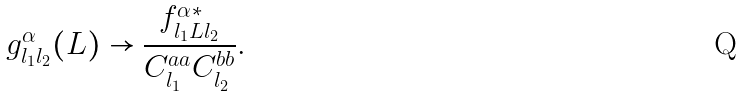<formula> <loc_0><loc_0><loc_500><loc_500>g ^ { \alpha } _ { l _ { 1 } l _ { 2 } } ( L ) \rightarrow \frac { f ^ { \alpha * } _ { l _ { 1 } L l _ { 2 } } } { C _ { l _ { 1 } } ^ { a a } C _ { l _ { 2 } } ^ { b b } } .</formula> 